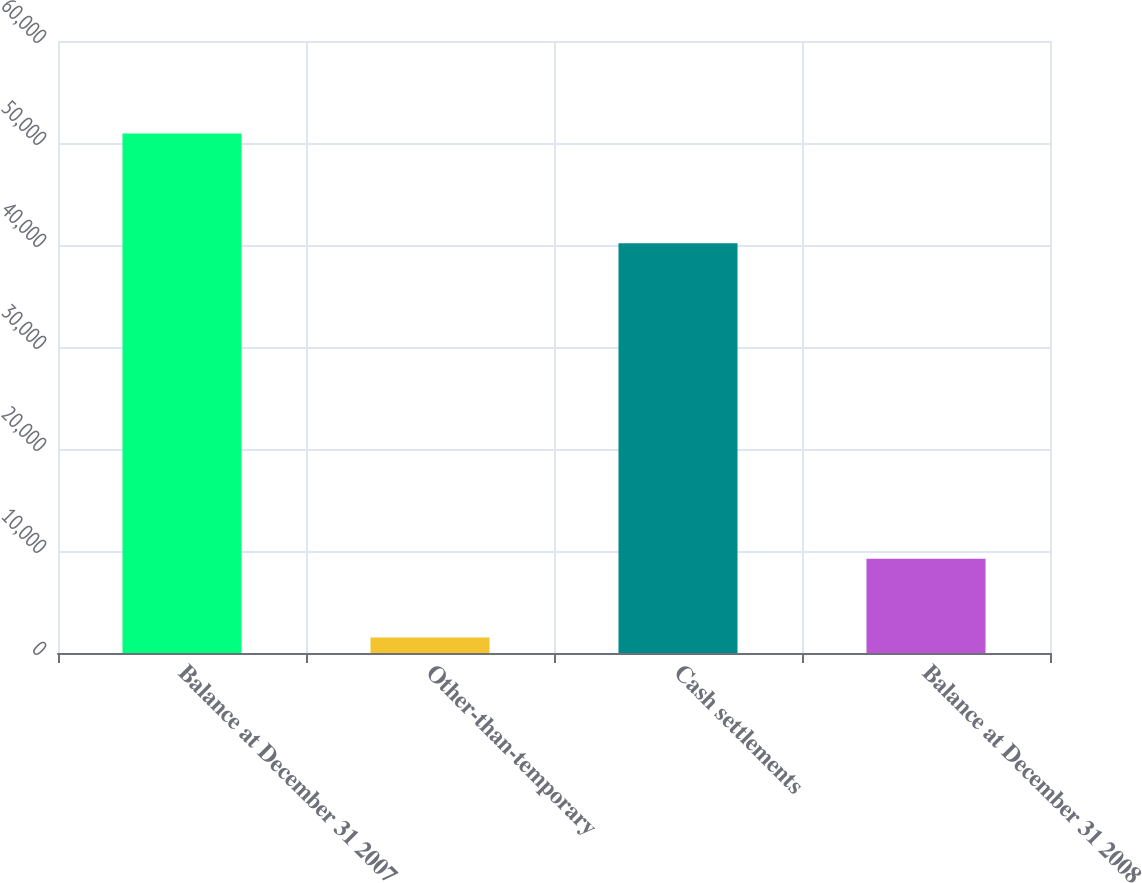Convert chart. <chart><loc_0><loc_0><loc_500><loc_500><bar_chart><fcel>Balance at December 31 2007<fcel>Other-than-temporary<fcel>Cash settlements<fcel>Balance at December 31 2008<nl><fcel>50940<fcel>1527<fcel>40163<fcel>9250<nl></chart> 